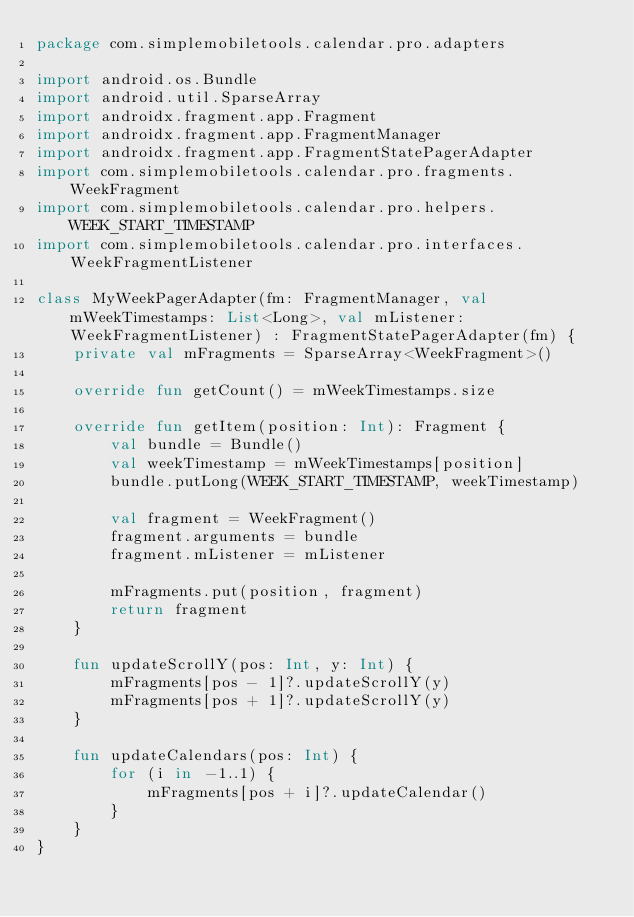Convert code to text. <code><loc_0><loc_0><loc_500><loc_500><_Kotlin_>package com.simplemobiletools.calendar.pro.adapters

import android.os.Bundle
import android.util.SparseArray
import androidx.fragment.app.Fragment
import androidx.fragment.app.FragmentManager
import androidx.fragment.app.FragmentStatePagerAdapter
import com.simplemobiletools.calendar.pro.fragments.WeekFragment
import com.simplemobiletools.calendar.pro.helpers.WEEK_START_TIMESTAMP
import com.simplemobiletools.calendar.pro.interfaces.WeekFragmentListener

class MyWeekPagerAdapter(fm: FragmentManager, val mWeekTimestamps: List<Long>, val mListener: WeekFragmentListener) : FragmentStatePagerAdapter(fm) {
    private val mFragments = SparseArray<WeekFragment>()

    override fun getCount() = mWeekTimestamps.size

    override fun getItem(position: Int): Fragment {
        val bundle = Bundle()
        val weekTimestamp = mWeekTimestamps[position]
        bundle.putLong(WEEK_START_TIMESTAMP, weekTimestamp)

        val fragment = WeekFragment()
        fragment.arguments = bundle
        fragment.mListener = mListener

        mFragments.put(position, fragment)
        return fragment
    }

    fun updateScrollY(pos: Int, y: Int) {
        mFragments[pos - 1]?.updateScrollY(y)
        mFragments[pos + 1]?.updateScrollY(y)
    }

    fun updateCalendars(pos: Int) {
        for (i in -1..1) {
            mFragments[pos + i]?.updateCalendar()
        }
    }
}
</code> 